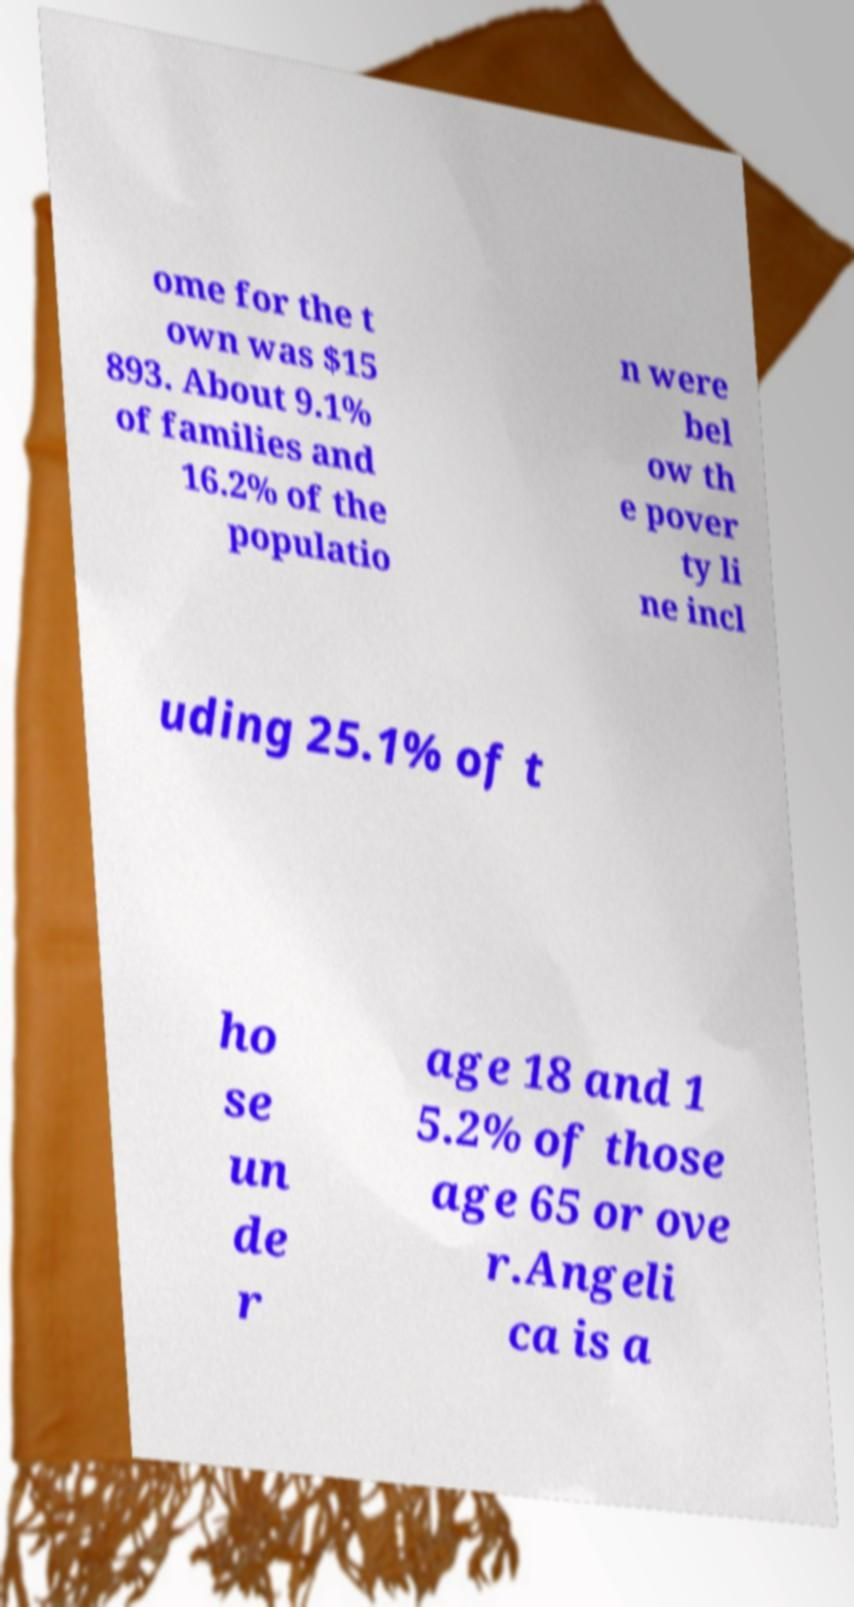Could you extract and type out the text from this image? ome for the t own was $15 893. About 9.1% of families and 16.2% of the populatio n were bel ow th e pover ty li ne incl uding 25.1% of t ho se un de r age 18 and 1 5.2% of those age 65 or ove r.Angeli ca is a 